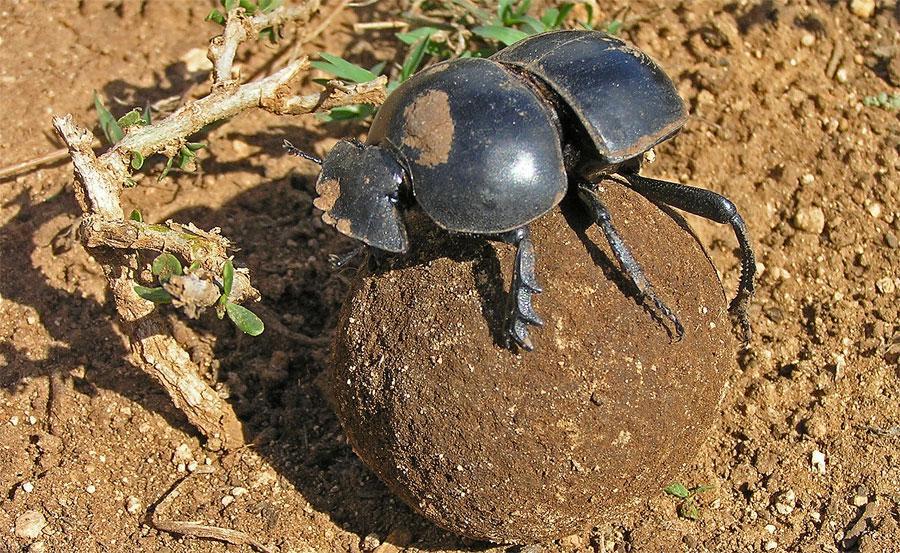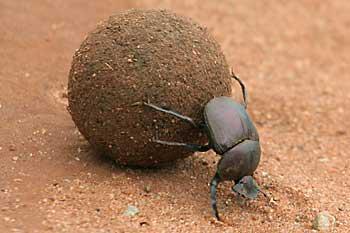The first image is the image on the left, the second image is the image on the right. Analyze the images presented: Is the assertion "In the image on the left, there is no more than one beetle present, industriously building the dung ball." valid? Answer yes or no. Yes. The first image is the image on the left, the second image is the image on the right. Assess this claim about the two images: "There is at most three beetles.". Correct or not? Answer yes or no. Yes. 